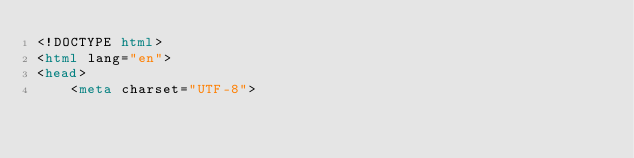Convert code to text. <code><loc_0><loc_0><loc_500><loc_500><_HTML_><!DOCTYPE html>
<html lang="en">
<head>
    <meta charset="UTF-8"></code> 